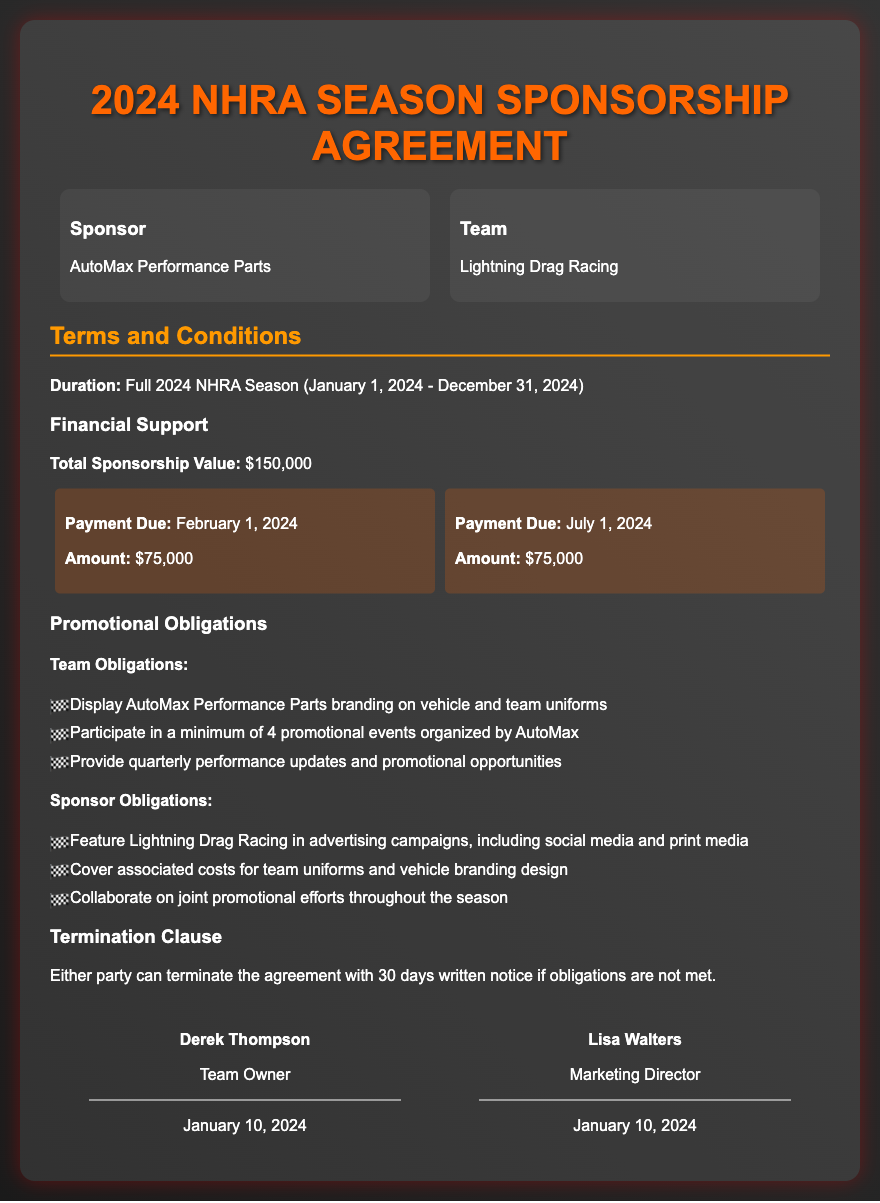What is the total sponsorship value? The total sponsorship value is listed under Financial Support in the document.
Answer: $150,000 When is the first payment due? The first payment due date is stated in the payment schedule of the document.
Answer: February 1, 2024 How many promotional events must the team participate in? The number of promotional events is specified under Team Obligations.
Answer: 4 Who is the Team Owner? The Team Owner's name is mentioned in the signatures section of the document.
Answer: Derek Thompson What happens if obligations are not met? The consequences for not meeting obligations are described in the Termination Clause.
Answer: 30 days written notice for termination Which company is listed as the Sponsor? The Sponsor's name is provided in the parties section at the beginning of the document.
Answer: AutoMax Performance Parts What is one of the Sponsor's obligations? The obligations of the Sponsor are listed under Sponsor Obligations.
Answer: Feature Lightning Drag Racing in advertising campaigns When does the sponsorship agreement last until? The duration of the agreement is specified at the beginning of the terms and conditions section.
Answer: December 31, 2024 